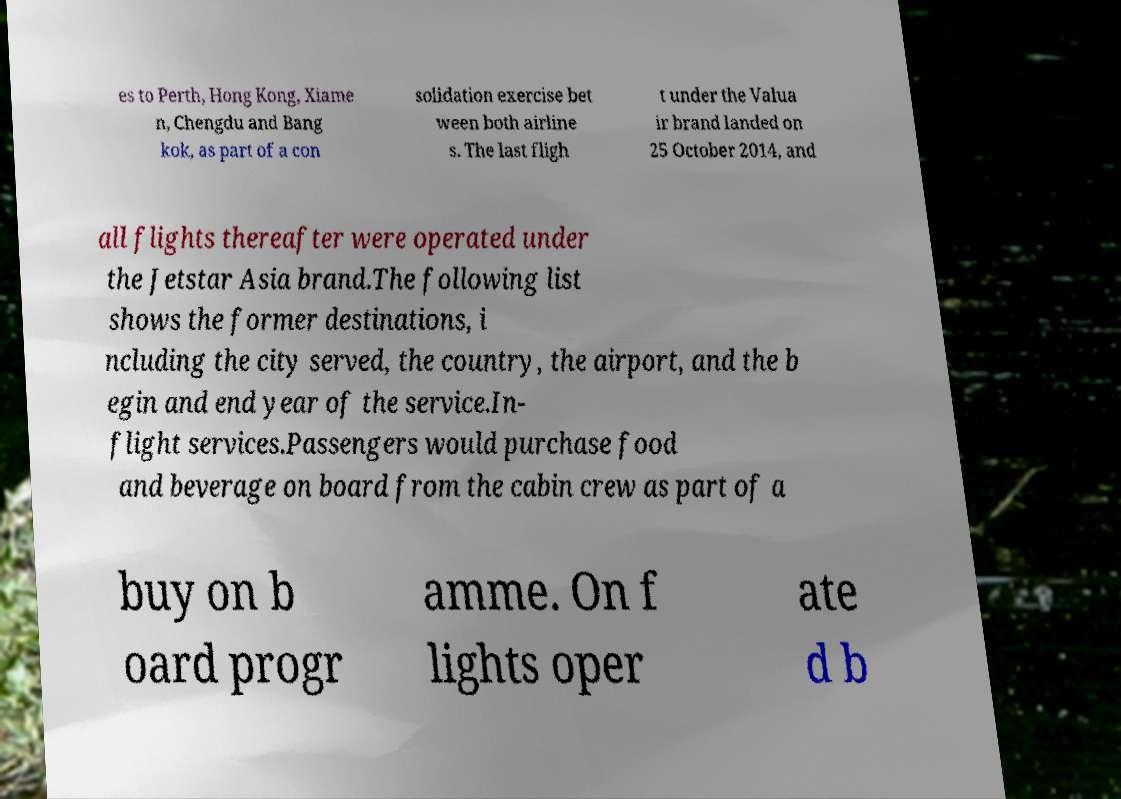Could you assist in decoding the text presented in this image and type it out clearly? es to Perth, Hong Kong, Xiame n, Chengdu and Bang kok, as part of a con solidation exercise bet ween both airline s. The last fligh t under the Valua ir brand landed on 25 October 2014, and all flights thereafter were operated under the Jetstar Asia brand.The following list shows the former destinations, i ncluding the city served, the country, the airport, and the b egin and end year of the service.In- flight services.Passengers would purchase food and beverage on board from the cabin crew as part of a buy on b oard progr amme. On f lights oper ate d b 